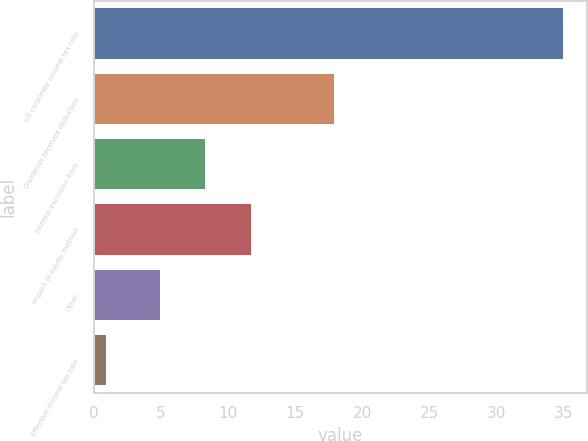Convert chart. <chart><loc_0><loc_0><loc_500><loc_500><bar_chart><fcel>US corporate income tax rate<fcel>Dividends received deduction<fcel>Interest exclusion from<fcel>Impact of equity method<fcel>Other<fcel>Effective income tax rate<nl><fcel>35<fcel>18<fcel>8.4<fcel>11.8<fcel>5<fcel>1<nl></chart> 